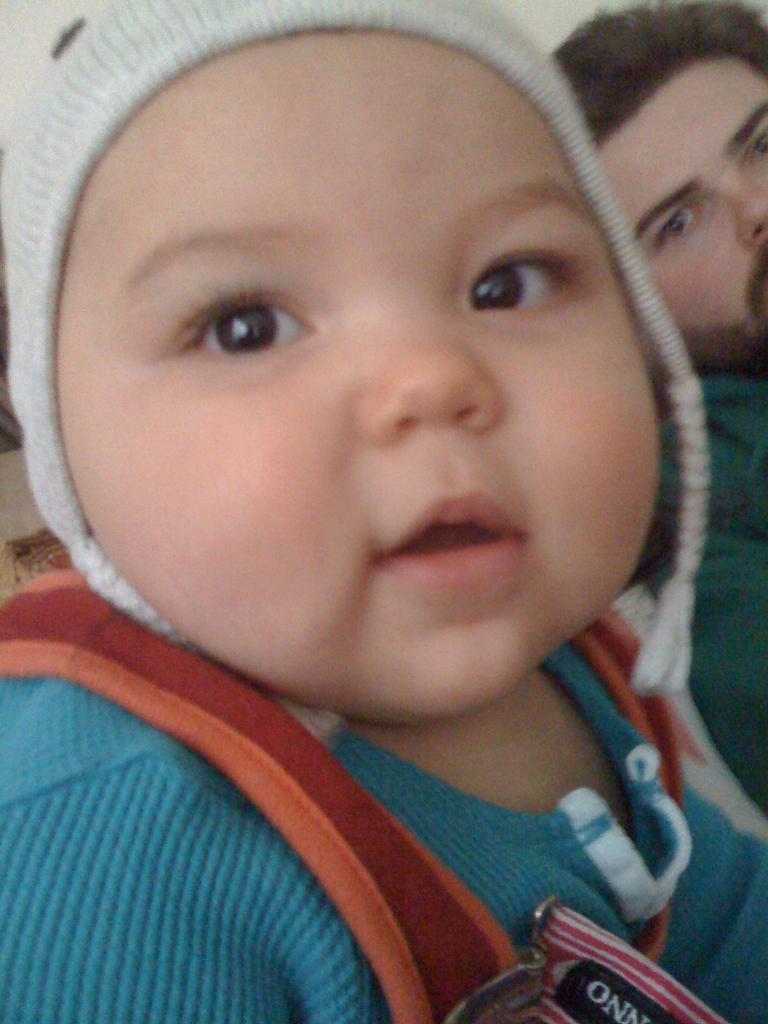Can you describe this image briefly? In this picture we can observe baby wearing a cap on his head and a blue color t-shirt. Behind him there is a person in the background. 